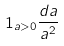<formula> <loc_0><loc_0><loc_500><loc_500>1 _ { a > 0 } \frac { d a } { a ^ { 2 } }</formula> 